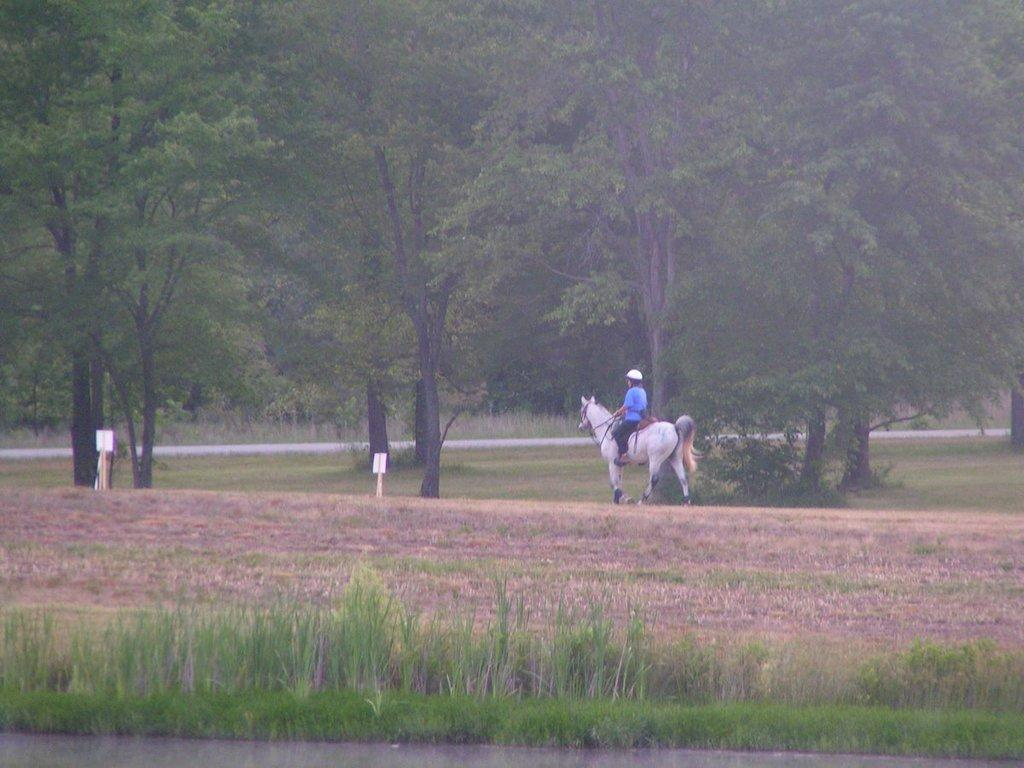What is in the foreground of the image? There is grass in the foreground of the image. What activity is taking place in the image? A person is riding a horse on the ground. What can be seen in the background of the image? There are boards and trees in the background of the image. When was the image likely taken? The image appears to have been taken during the day. What type of stocking is being used to secure the screw in the middle of the image? There is no stocking or screw present in the image; it features a person riding a horse on the ground with grass in the foreground and boards and trees in the background. 